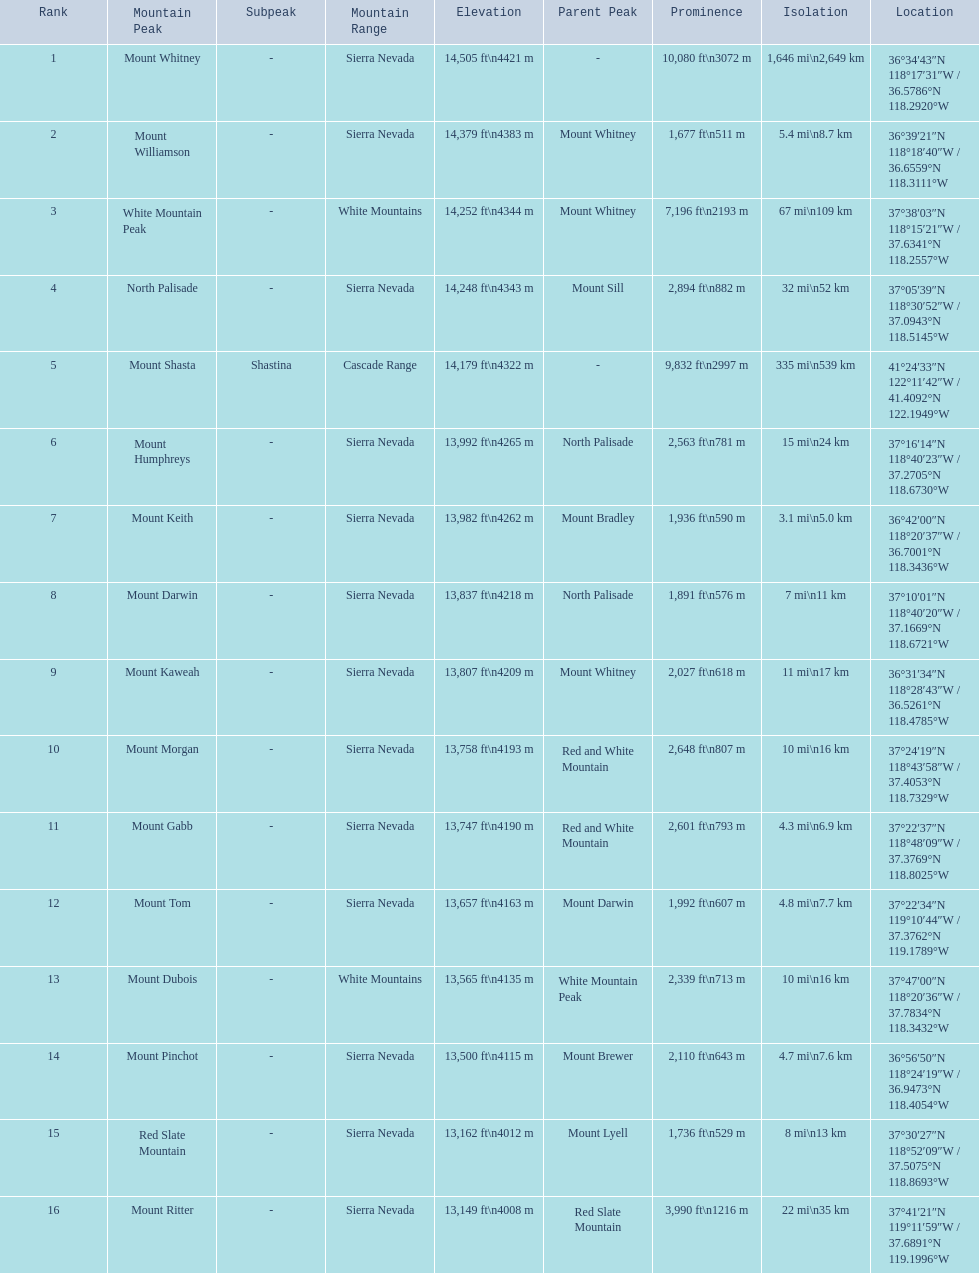What mountain peak is listed for the sierra nevada mountain range? Mount Whitney. What mountain peak has an elevation of 14,379ft? Mount Williamson. Which mountain is listed for the cascade range? Mount Shasta. 